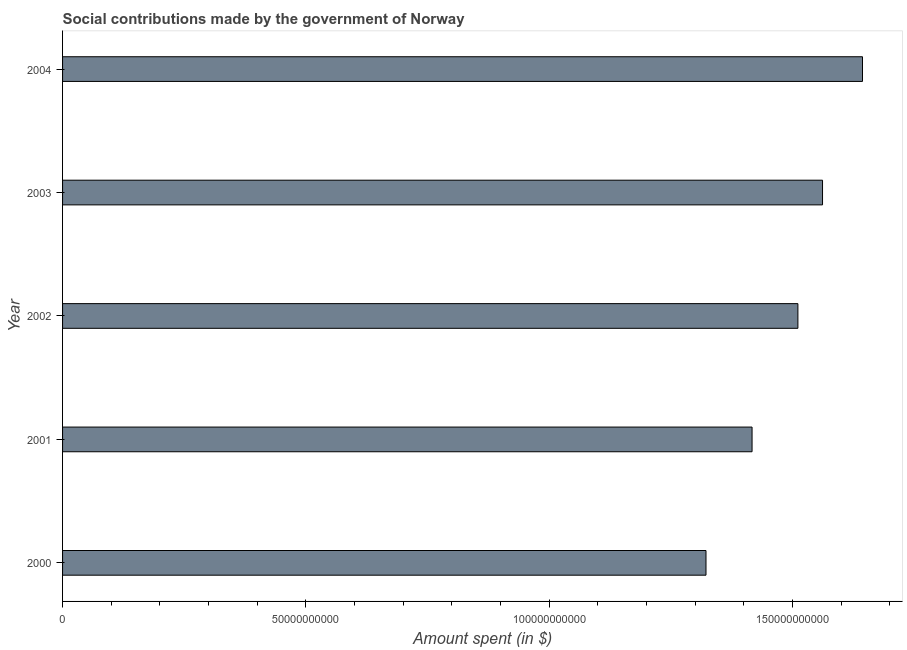Does the graph contain any zero values?
Make the answer very short. No. Does the graph contain grids?
Ensure brevity in your answer.  No. What is the title of the graph?
Offer a terse response. Social contributions made by the government of Norway. What is the label or title of the X-axis?
Your answer should be compact. Amount spent (in $). What is the amount spent in making social contributions in 2000?
Your response must be concise. 1.32e+11. Across all years, what is the maximum amount spent in making social contributions?
Offer a very short reply. 1.64e+11. Across all years, what is the minimum amount spent in making social contributions?
Give a very brief answer. 1.32e+11. What is the sum of the amount spent in making social contributions?
Give a very brief answer. 7.46e+11. What is the difference between the amount spent in making social contributions in 2001 and 2004?
Provide a succinct answer. -2.27e+1. What is the average amount spent in making social contributions per year?
Your answer should be compact. 1.49e+11. What is the median amount spent in making social contributions?
Your response must be concise. 1.51e+11. In how many years, is the amount spent in making social contributions greater than 10000000000 $?
Your answer should be very brief. 5. What is the ratio of the amount spent in making social contributions in 2001 to that in 2004?
Provide a succinct answer. 0.86. Is the amount spent in making social contributions in 2001 less than that in 2004?
Offer a terse response. Yes. Is the difference between the amount spent in making social contributions in 2000 and 2003 greater than the difference between any two years?
Provide a short and direct response. No. What is the difference between the highest and the second highest amount spent in making social contributions?
Give a very brief answer. 8.21e+09. Is the sum of the amount spent in making social contributions in 2000 and 2003 greater than the maximum amount spent in making social contributions across all years?
Provide a succinct answer. Yes. What is the difference between the highest and the lowest amount spent in making social contributions?
Give a very brief answer. 3.22e+1. How many bars are there?
Provide a short and direct response. 5. Are all the bars in the graph horizontal?
Your response must be concise. Yes. How many years are there in the graph?
Give a very brief answer. 5. What is the difference between two consecutive major ticks on the X-axis?
Offer a terse response. 5.00e+1. What is the Amount spent (in $) in 2000?
Give a very brief answer. 1.32e+11. What is the Amount spent (in $) in 2001?
Your response must be concise. 1.42e+11. What is the Amount spent (in $) in 2002?
Your answer should be compact. 1.51e+11. What is the Amount spent (in $) in 2003?
Your answer should be very brief. 1.56e+11. What is the Amount spent (in $) in 2004?
Ensure brevity in your answer.  1.64e+11. What is the difference between the Amount spent (in $) in 2000 and 2001?
Provide a short and direct response. -9.47e+09. What is the difference between the Amount spent (in $) in 2000 and 2002?
Your answer should be compact. -1.89e+1. What is the difference between the Amount spent (in $) in 2000 and 2003?
Your answer should be compact. -2.39e+1. What is the difference between the Amount spent (in $) in 2000 and 2004?
Give a very brief answer. -3.22e+1. What is the difference between the Amount spent (in $) in 2001 and 2002?
Keep it short and to the point. -9.42e+09. What is the difference between the Amount spent (in $) in 2001 and 2003?
Your response must be concise. -1.45e+1. What is the difference between the Amount spent (in $) in 2001 and 2004?
Ensure brevity in your answer.  -2.27e+1. What is the difference between the Amount spent (in $) in 2002 and 2003?
Give a very brief answer. -5.06e+09. What is the difference between the Amount spent (in $) in 2002 and 2004?
Provide a succinct answer. -1.33e+1. What is the difference between the Amount spent (in $) in 2003 and 2004?
Provide a succinct answer. -8.21e+09. What is the ratio of the Amount spent (in $) in 2000 to that in 2001?
Provide a short and direct response. 0.93. What is the ratio of the Amount spent (in $) in 2000 to that in 2002?
Offer a very short reply. 0.88. What is the ratio of the Amount spent (in $) in 2000 to that in 2003?
Your answer should be very brief. 0.85. What is the ratio of the Amount spent (in $) in 2000 to that in 2004?
Provide a succinct answer. 0.8. What is the ratio of the Amount spent (in $) in 2001 to that in 2002?
Give a very brief answer. 0.94. What is the ratio of the Amount spent (in $) in 2001 to that in 2003?
Give a very brief answer. 0.91. What is the ratio of the Amount spent (in $) in 2001 to that in 2004?
Keep it short and to the point. 0.86. What is the ratio of the Amount spent (in $) in 2002 to that in 2003?
Provide a short and direct response. 0.97. What is the ratio of the Amount spent (in $) in 2002 to that in 2004?
Provide a succinct answer. 0.92. 